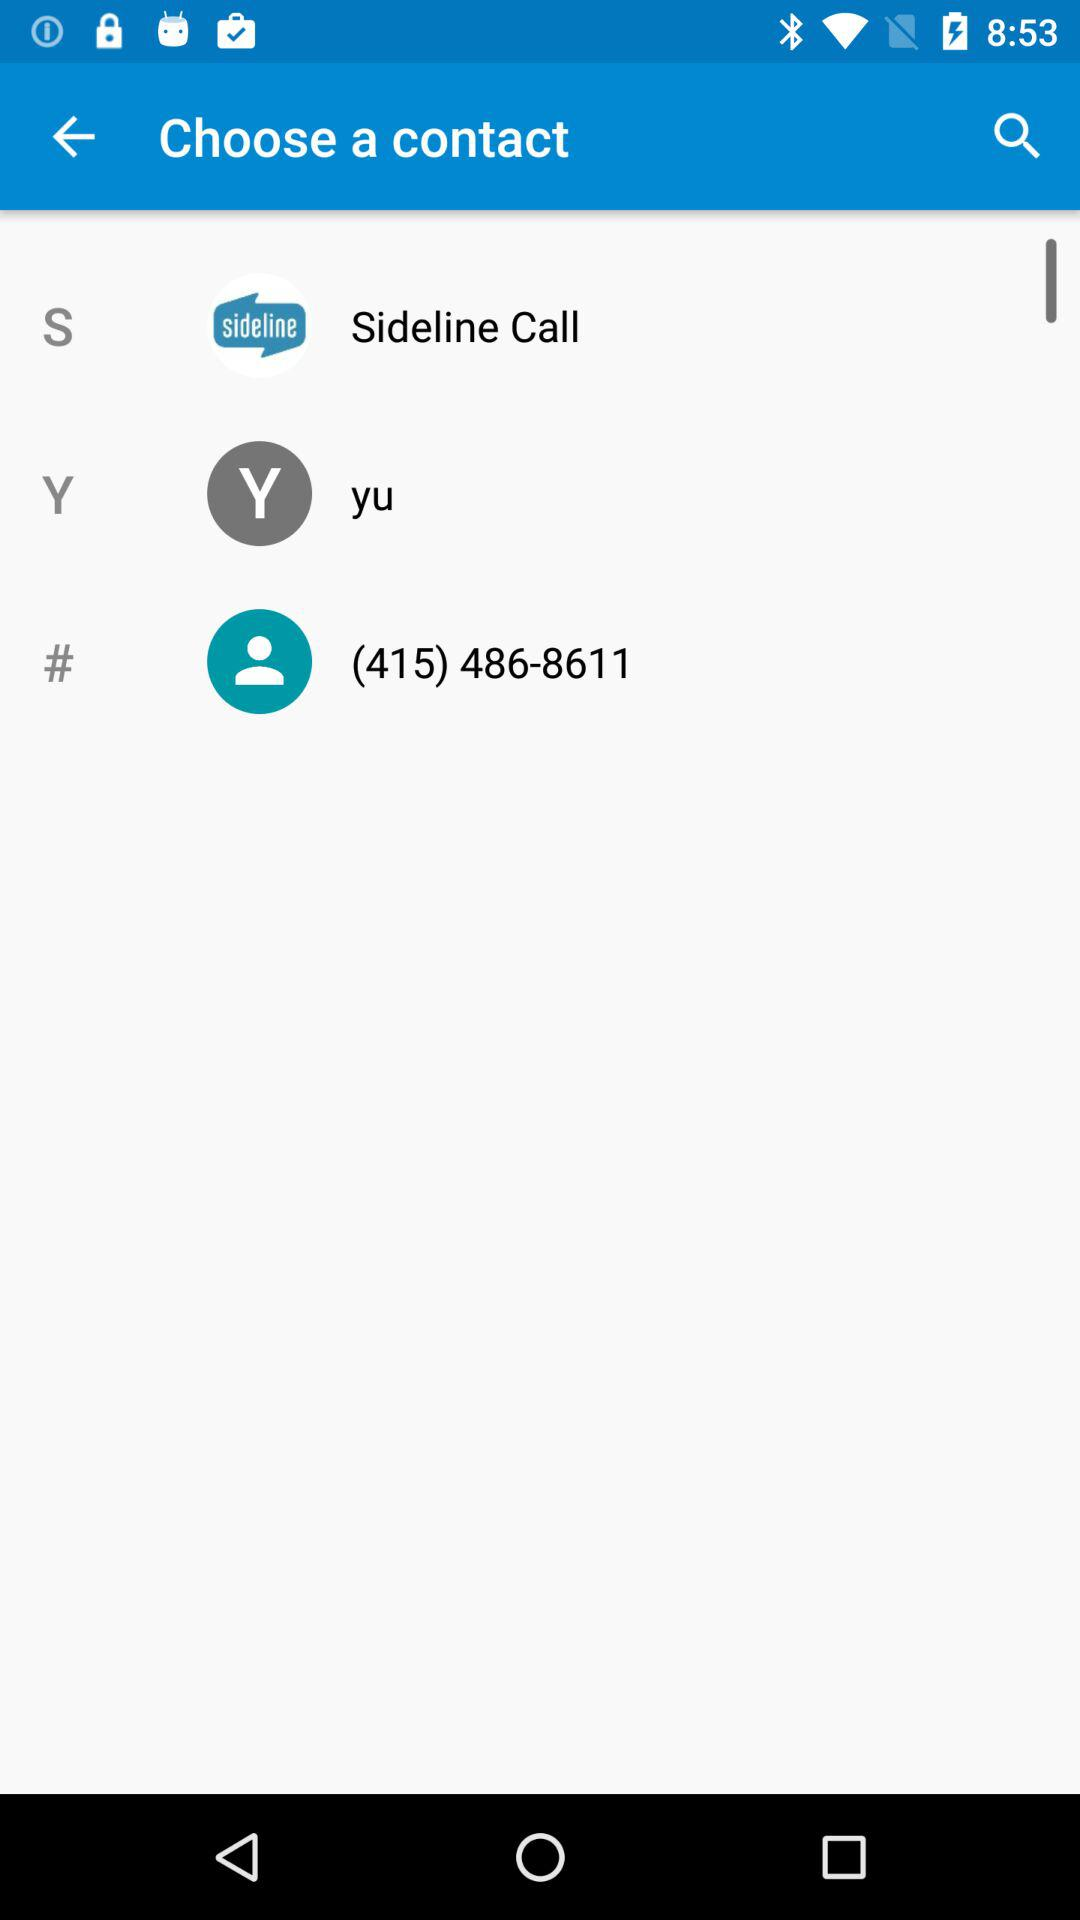What's the contact number? The contact number is "(415) 486-8611". 